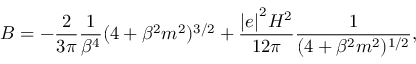Convert formula to latex. <formula><loc_0><loc_0><loc_500><loc_500>B = - \frac { 2 } { 3 \pi } \frac { 1 } { \beta ^ { 4 } } ( 4 + \beta ^ { 2 } m ^ { 2 } ) ^ { 3 / 2 } + \frac { { | e | } ^ { 2 } H ^ { 2 } } { 1 2 \pi } \frac { 1 } { ( 4 + \beta ^ { 2 } m ^ { 2 } ) ^ { 1 / 2 } } ,</formula> 